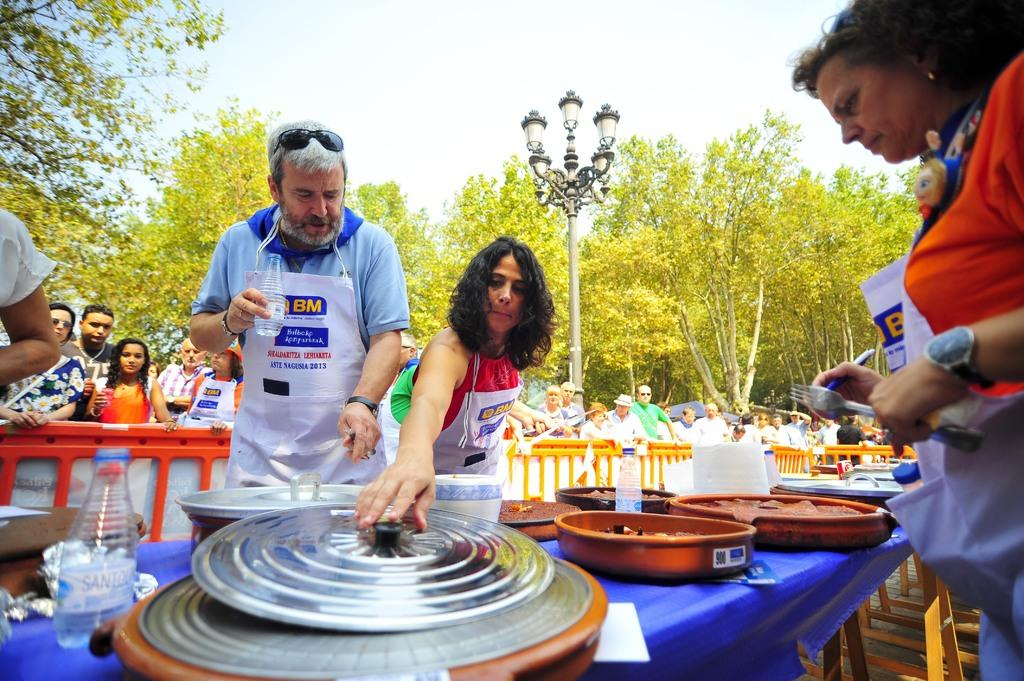How many people are seated at the table in the image? There are 4 people at the table in the image. What can be found on the table besides the people? Food items and bottles are present on the table. Can you describe the scene behind the table? There are people visible behind the table, and there is a fence, a pole, a light, trees, and the sky visible in the background. What type of polish is being applied to the shoes in the image? There are no shoes or polish present in the image. Can you describe the rat's behavior in the image? There is no rat present in the image. 